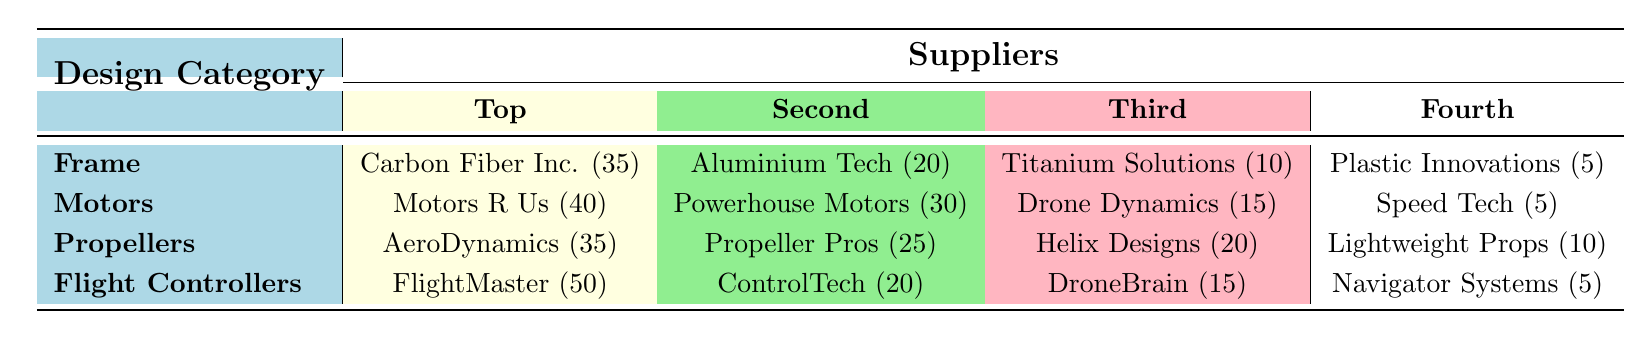What is the top supplier for Frame category? The top supplier for the Frame category is listed as Carbon Fiber Inc. with a frequency of 35. This is easily found in the first row of the table under the Frame category.
Answer: Carbon Fiber Inc How many suppliers are listed for the Propellers category? The Propellers category has four suppliers listed: AeroDynamics, Propeller Pros, Helix Designs, and Lightweight Props. This is clear from the table as there are four entries under the Propellers row.
Answer: Four What is the total frequency of suppliers for the Motors category? To get the total frequency for the Motors category, we sum the frequencies of all four suppliers: 40 + 30 + 15 + 5 = 90. This calculation involves simply adding the values provided in that row of the table.
Answer: 90 Which category has the highest frequency of components overall? By comparing the total frequencies for each category: Frame (70), Motors (90), Propellers (90), and Flight Controllers (90), we find that Motors, Propellers, and Flight Controllers all tie for the highest frequency of 90. This requires checking each category's total.
Answer: Motors, Propellers, Flight Controllers Is Plastic Innovations one of the top three suppliers for any category? Looking at the categories, Plastic Innovations ranks fourth in the Frame category and is not included in the top three suppliers for any other category. Therefore, it is not among the top three suppliers in any category. This is verified by the entries in the table.
Answer: No What is the difference in the frequency of the top supplier for Flight Controllers and the second supplier for the same category? The top supplier for Flight Controllers is FlightMaster with a frequency of 50, and the second supplier is ControlTech with a frequency of 20. The difference is calculated as 50 - 20 = 30, which is derived from subtracting the second value from the first.
Answer: 30 Which supplier has the lowest frequency across all categories? Among all the suppliers listed, Plastic Innovations (5) and Speed Tech (5) both have the lowest frequency of 5, which we can determine by checking the lowest value in the frequency counts across the entire table.
Answer: Plastic Innovations, Speed Tech What is the average frequency of suppliers for the Frame category? To calculate the average frequency, we add the frequencies of all the suppliers in the Frame category (35 + 20 + 10 + 5 = 70) and then divide by the number of suppliers (4). This gives an average of 70/4 = 17.5. The calculation involves both addition and division.
Answer: 17.5 